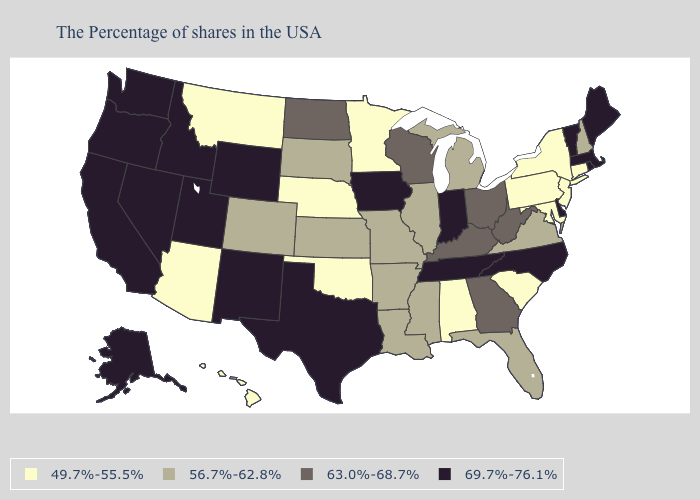Does the map have missing data?
Quick response, please. No. Does West Virginia have the highest value in the USA?
Give a very brief answer. No. Name the states that have a value in the range 49.7%-55.5%?
Be succinct. Connecticut, New York, New Jersey, Maryland, Pennsylvania, South Carolina, Alabama, Minnesota, Nebraska, Oklahoma, Montana, Arizona, Hawaii. Does Montana have the lowest value in the USA?
Concise answer only. Yes. What is the value of Kentucky?
Keep it brief. 63.0%-68.7%. What is the value of Washington?
Write a very short answer. 69.7%-76.1%. What is the lowest value in the USA?
Short answer required. 49.7%-55.5%. Is the legend a continuous bar?
Short answer required. No. What is the value of California?
Short answer required. 69.7%-76.1%. Name the states that have a value in the range 49.7%-55.5%?
Quick response, please. Connecticut, New York, New Jersey, Maryland, Pennsylvania, South Carolina, Alabama, Minnesota, Nebraska, Oklahoma, Montana, Arizona, Hawaii. Does South Carolina have the lowest value in the South?
Write a very short answer. Yes. Among the states that border Kentucky , does Ohio have the lowest value?
Quick response, please. No. What is the value of Connecticut?
Write a very short answer. 49.7%-55.5%. Does New Mexico have the lowest value in the West?
Give a very brief answer. No. Does the first symbol in the legend represent the smallest category?
Write a very short answer. Yes. 